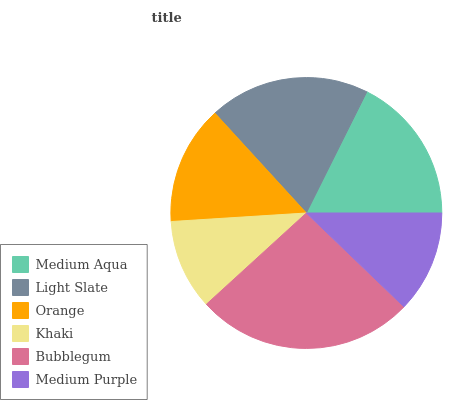Is Khaki the minimum?
Answer yes or no. Yes. Is Bubblegum the maximum?
Answer yes or no. Yes. Is Light Slate the minimum?
Answer yes or no. No. Is Light Slate the maximum?
Answer yes or no. No. Is Light Slate greater than Medium Aqua?
Answer yes or no. Yes. Is Medium Aqua less than Light Slate?
Answer yes or no. Yes. Is Medium Aqua greater than Light Slate?
Answer yes or no. No. Is Light Slate less than Medium Aqua?
Answer yes or no. No. Is Medium Aqua the high median?
Answer yes or no. Yes. Is Orange the low median?
Answer yes or no. Yes. Is Bubblegum the high median?
Answer yes or no. No. Is Khaki the low median?
Answer yes or no. No. 